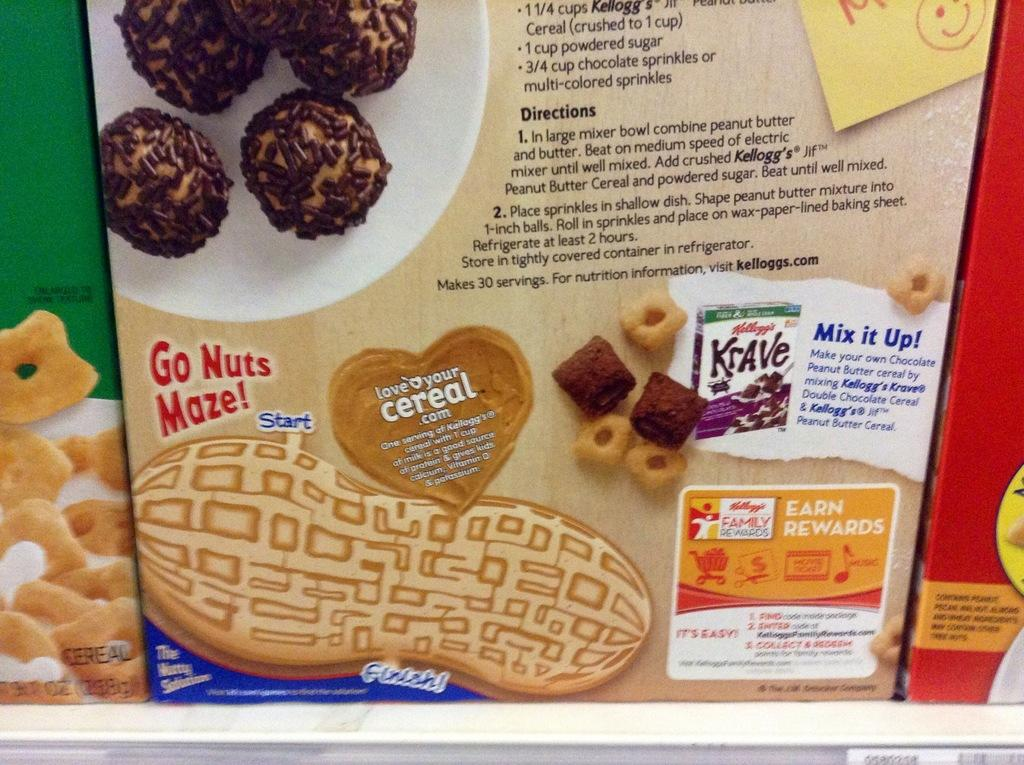What objects are present in the image? There are boxes in the image. Can you describe the appearance of the boxes? The boxes are in multiple colors. What else can be seen in the image besides the boxes? There are chocolates visible in the image. Is there any text or writing on the boxes? Yes, there is writing on the boxes. How many times does the person in the image sneeze while holding the crook? There is no person or crook present in the image; it only features boxes and chocolates. 